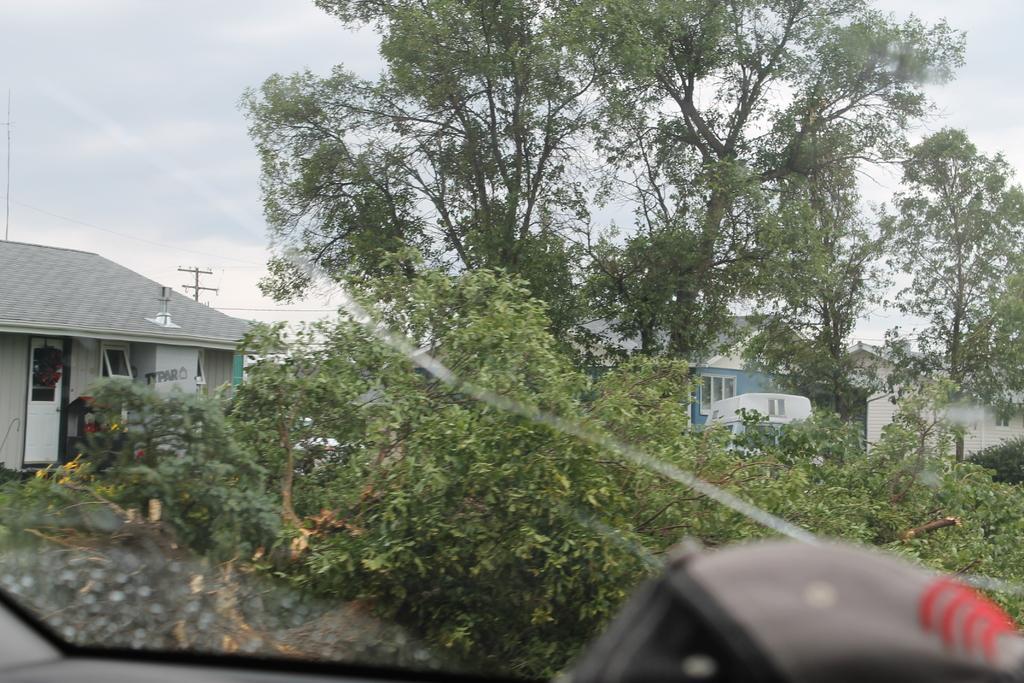Please provide a concise description of this image. In this image we can see buildings, trees, electric pole, electric cables and sky with clouds through a motor vehicle's window. 